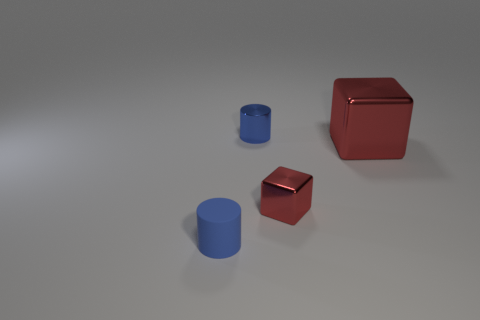Do the tiny blue matte object and the large thing have the same shape?
Make the answer very short. No. What number of metal blocks are on the left side of the big red block and to the right of the tiny red metallic cube?
Your answer should be very brief. 0. Is the number of tiny red shiny cubes left of the small blue metal thing the same as the number of tiny metallic objects that are on the left side of the small red metallic cube?
Your answer should be compact. No. There is a blue object that is behind the large red cube; is it the same size as the red object that is behind the tiny red shiny block?
Your response must be concise. No. What is the material of the object that is both in front of the big red metallic object and on the right side of the tiny blue rubber cylinder?
Ensure brevity in your answer.  Metal. Are there fewer tiny objects than rubber objects?
Ensure brevity in your answer.  No. What size is the blue cylinder that is in front of the small cylinder behind the tiny blue rubber object?
Your response must be concise. Small. There is a blue thing on the left side of the tiny cylinder that is behind the red object to the right of the small metallic block; what shape is it?
Keep it short and to the point. Cylinder. There is a tiny cylinder that is the same material as the tiny red block; what color is it?
Give a very brief answer. Blue. The small metal object that is in front of the small blue object behind the tiny object that is on the left side of the metallic cylinder is what color?
Your answer should be compact. Red. 